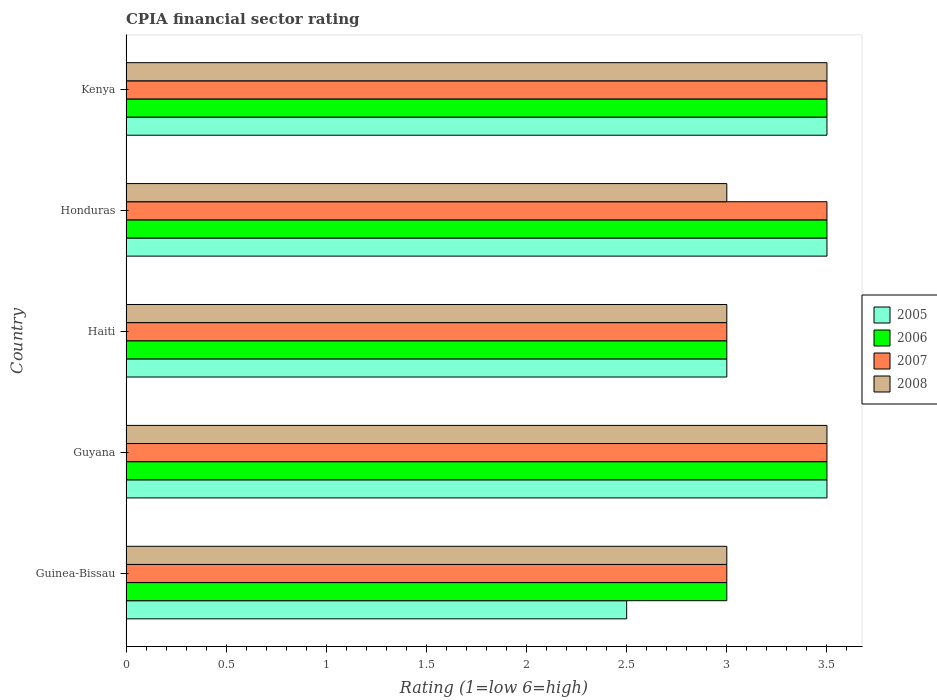How many different coloured bars are there?
Provide a short and direct response. 4. Are the number of bars per tick equal to the number of legend labels?
Provide a succinct answer. Yes. How many bars are there on the 4th tick from the bottom?
Your response must be concise. 4. What is the label of the 2nd group of bars from the top?
Offer a terse response. Honduras. Across all countries, what is the maximum CPIA rating in 2008?
Your answer should be very brief. 3.5. Across all countries, what is the minimum CPIA rating in 2007?
Offer a terse response. 3. In which country was the CPIA rating in 2006 maximum?
Make the answer very short. Guyana. In which country was the CPIA rating in 2007 minimum?
Your answer should be compact. Guinea-Bissau. What is the difference between the CPIA rating in 2007 in Kenya and the CPIA rating in 2008 in Honduras?
Give a very brief answer. 0.5. In how many countries, is the CPIA rating in 2007 greater than 1.6 ?
Provide a succinct answer. 5. What is the ratio of the CPIA rating in 2006 in Guinea-Bissau to that in Honduras?
Make the answer very short. 0.86. Is the CPIA rating in 2005 in Guyana less than that in Honduras?
Give a very brief answer. No. What is the difference between the highest and the lowest CPIA rating in 2006?
Your answer should be very brief. 0.5. In how many countries, is the CPIA rating in 2006 greater than the average CPIA rating in 2006 taken over all countries?
Provide a succinct answer. 3. Is it the case that in every country, the sum of the CPIA rating in 2007 and CPIA rating in 2006 is greater than the sum of CPIA rating in 2005 and CPIA rating in 2008?
Make the answer very short. No. What does the 3rd bar from the bottom in Guinea-Bissau represents?
Your answer should be very brief. 2007. How many bars are there?
Your answer should be very brief. 20. Are all the bars in the graph horizontal?
Keep it short and to the point. Yes. How many countries are there in the graph?
Your response must be concise. 5. What is the difference between two consecutive major ticks on the X-axis?
Keep it short and to the point. 0.5. Where does the legend appear in the graph?
Ensure brevity in your answer.  Center right. How many legend labels are there?
Make the answer very short. 4. How are the legend labels stacked?
Provide a short and direct response. Vertical. What is the title of the graph?
Your answer should be compact. CPIA financial sector rating. Does "2011" appear as one of the legend labels in the graph?
Ensure brevity in your answer.  No. What is the label or title of the Y-axis?
Make the answer very short. Country. What is the Rating (1=low 6=high) of 2005 in Guinea-Bissau?
Provide a short and direct response. 2.5. What is the Rating (1=low 6=high) of 2007 in Guinea-Bissau?
Make the answer very short. 3. What is the Rating (1=low 6=high) in 2006 in Guyana?
Ensure brevity in your answer.  3.5. What is the Rating (1=low 6=high) in 2008 in Guyana?
Offer a terse response. 3.5. What is the Rating (1=low 6=high) of 2008 in Haiti?
Make the answer very short. 3. What is the Rating (1=low 6=high) in 2006 in Honduras?
Make the answer very short. 3.5. What is the Rating (1=low 6=high) of 2008 in Honduras?
Your answer should be compact. 3. What is the Rating (1=low 6=high) of 2006 in Kenya?
Offer a very short reply. 3.5. What is the Rating (1=low 6=high) of 2008 in Kenya?
Offer a very short reply. 3.5. Across all countries, what is the maximum Rating (1=low 6=high) of 2005?
Make the answer very short. 3.5. Across all countries, what is the minimum Rating (1=low 6=high) of 2005?
Your answer should be compact. 2.5. Across all countries, what is the minimum Rating (1=low 6=high) in 2006?
Offer a very short reply. 3. Across all countries, what is the minimum Rating (1=low 6=high) in 2007?
Give a very brief answer. 3. What is the difference between the Rating (1=low 6=high) of 2007 in Guinea-Bissau and that in Guyana?
Make the answer very short. -0.5. What is the difference between the Rating (1=low 6=high) of 2008 in Guinea-Bissau and that in Guyana?
Your response must be concise. -0.5. What is the difference between the Rating (1=low 6=high) in 2006 in Guinea-Bissau and that in Haiti?
Offer a terse response. 0. What is the difference between the Rating (1=low 6=high) of 2005 in Guinea-Bissau and that in Kenya?
Ensure brevity in your answer.  -1. What is the difference between the Rating (1=low 6=high) of 2007 in Guinea-Bissau and that in Kenya?
Keep it short and to the point. -0.5. What is the difference between the Rating (1=low 6=high) of 2008 in Guinea-Bissau and that in Kenya?
Provide a short and direct response. -0.5. What is the difference between the Rating (1=low 6=high) of 2005 in Guyana and that in Haiti?
Your answer should be very brief. 0.5. What is the difference between the Rating (1=low 6=high) of 2007 in Guyana and that in Haiti?
Your answer should be compact. 0.5. What is the difference between the Rating (1=low 6=high) in 2008 in Guyana and that in Haiti?
Keep it short and to the point. 0.5. What is the difference between the Rating (1=low 6=high) in 2007 in Guyana and that in Honduras?
Your response must be concise. 0. What is the difference between the Rating (1=low 6=high) in 2005 in Guyana and that in Kenya?
Provide a succinct answer. 0. What is the difference between the Rating (1=low 6=high) in 2006 in Guyana and that in Kenya?
Give a very brief answer. 0. What is the difference between the Rating (1=low 6=high) of 2007 in Guyana and that in Kenya?
Offer a very short reply. 0. What is the difference between the Rating (1=low 6=high) in 2008 in Guyana and that in Kenya?
Ensure brevity in your answer.  0. What is the difference between the Rating (1=low 6=high) in 2005 in Haiti and that in Honduras?
Your answer should be very brief. -0.5. What is the difference between the Rating (1=low 6=high) of 2007 in Haiti and that in Honduras?
Your answer should be compact. -0.5. What is the difference between the Rating (1=low 6=high) in 2006 in Honduras and that in Kenya?
Your response must be concise. 0. What is the difference between the Rating (1=low 6=high) in 2005 in Guinea-Bissau and the Rating (1=low 6=high) in 2006 in Guyana?
Make the answer very short. -1. What is the difference between the Rating (1=low 6=high) in 2006 in Guinea-Bissau and the Rating (1=low 6=high) in 2008 in Guyana?
Your answer should be compact. -0.5. What is the difference between the Rating (1=low 6=high) in 2007 in Guinea-Bissau and the Rating (1=low 6=high) in 2008 in Guyana?
Ensure brevity in your answer.  -0.5. What is the difference between the Rating (1=low 6=high) of 2006 in Guinea-Bissau and the Rating (1=low 6=high) of 2008 in Haiti?
Provide a succinct answer. 0. What is the difference between the Rating (1=low 6=high) of 2007 in Guinea-Bissau and the Rating (1=low 6=high) of 2008 in Haiti?
Your response must be concise. 0. What is the difference between the Rating (1=low 6=high) in 2006 in Guinea-Bissau and the Rating (1=low 6=high) in 2008 in Honduras?
Your answer should be very brief. 0. What is the difference between the Rating (1=low 6=high) in 2007 in Guinea-Bissau and the Rating (1=low 6=high) in 2008 in Honduras?
Make the answer very short. 0. What is the difference between the Rating (1=low 6=high) of 2005 in Guinea-Bissau and the Rating (1=low 6=high) of 2007 in Kenya?
Ensure brevity in your answer.  -1. What is the difference between the Rating (1=low 6=high) of 2006 in Guinea-Bissau and the Rating (1=low 6=high) of 2008 in Kenya?
Your answer should be very brief. -0.5. What is the difference between the Rating (1=low 6=high) in 2007 in Guinea-Bissau and the Rating (1=low 6=high) in 2008 in Kenya?
Give a very brief answer. -0.5. What is the difference between the Rating (1=low 6=high) of 2005 in Guyana and the Rating (1=low 6=high) of 2007 in Haiti?
Offer a very short reply. 0.5. What is the difference between the Rating (1=low 6=high) in 2006 in Guyana and the Rating (1=low 6=high) in 2007 in Haiti?
Your answer should be very brief. 0.5. What is the difference between the Rating (1=low 6=high) of 2005 in Guyana and the Rating (1=low 6=high) of 2008 in Honduras?
Offer a very short reply. 0.5. What is the difference between the Rating (1=low 6=high) in 2006 in Guyana and the Rating (1=low 6=high) in 2007 in Honduras?
Your answer should be compact. 0. What is the difference between the Rating (1=low 6=high) in 2006 in Guyana and the Rating (1=low 6=high) in 2008 in Honduras?
Your answer should be very brief. 0.5. What is the difference between the Rating (1=low 6=high) in 2005 in Guyana and the Rating (1=low 6=high) in 2006 in Kenya?
Keep it short and to the point. 0. What is the difference between the Rating (1=low 6=high) in 2005 in Guyana and the Rating (1=low 6=high) in 2007 in Kenya?
Offer a terse response. 0. What is the difference between the Rating (1=low 6=high) in 2006 in Guyana and the Rating (1=low 6=high) in 2008 in Kenya?
Your answer should be compact. 0. What is the difference between the Rating (1=low 6=high) of 2007 in Guyana and the Rating (1=low 6=high) of 2008 in Kenya?
Keep it short and to the point. 0. What is the difference between the Rating (1=low 6=high) in 2005 in Haiti and the Rating (1=low 6=high) in 2007 in Honduras?
Your answer should be compact. -0.5. What is the difference between the Rating (1=low 6=high) in 2006 in Haiti and the Rating (1=low 6=high) in 2007 in Honduras?
Your answer should be compact. -0.5. What is the difference between the Rating (1=low 6=high) of 2005 in Haiti and the Rating (1=low 6=high) of 2006 in Kenya?
Offer a terse response. -0.5. What is the difference between the Rating (1=low 6=high) in 2005 in Haiti and the Rating (1=low 6=high) in 2007 in Kenya?
Provide a short and direct response. -0.5. What is the difference between the Rating (1=low 6=high) of 2005 in Haiti and the Rating (1=low 6=high) of 2008 in Kenya?
Make the answer very short. -0.5. What is the difference between the Rating (1=low 6=high) in 2006 in Haiti and the Rating (1=low 6=high) in 2007 in Kenya?
Ensure brevity in your answer.  -0.5. What is the difference between the Rating (1=low 6=high) of 2006 in Haiti and the Rating (1=low 6=high) of 2008 in Kenya?
Offer a terse response. -0.5. What is the difference between the Rating (1=low 6=high) in 2007 in Haiti and the Rating (1=low 6=high) in 2008 in Kenya?
Offer a terse response. -0.5. What is the difference between the Rating (1=low 6=high) in 2005 in Honduras and the Rating (1=low 6=high) in 2006 in Kenya?
Provide a short and direct response. 0. What is the difference between the Rating (1=low 6=high) in 2005 in Honduras and the Rating (1=low 6=high) in 2007 in Kenya?
Offer a very short reply. 0. What is the difference between the Rating (1=low 6=high) of 2006 in Honduras and the Rating (1=low 6=high) of 2007 in Kenya?
Provide a succinct answer. 0. What is the difference between the Rating (1=low 6=high) of 2006 in Honduras and the Rating (1=low 6=high) of 2008 in Kenya?
Offer a terse response. 0. What is the difference between the Rating (1=low 6=high) in 2007 in Honduras and the Rating (1=low 6=high) in 2008 in Kenya?
Your answer should be very brief. 0. What is the average Rating (1=low 6=high) in 2005 per country?
Give a very brief answer. 3.2. What is the average Rating (1=low 6=high) in 2008 per country?
Give a very brief answer. 3.2. What is the difference between the Rating (1=low 6=high) of 2006 and Rating (1=low 6=high) of 2007 in Guinea-Bissau?
Offer a very short reply. 0. What is the difference between the Rating (1=low 6=high) of 2006 and Rating (1=low 6=high) of 2008 in Guinea-Bissau?
Provide a succinct answer. 0. What is the difference between the Rating (1=low 6=high) in 2007 and Rating (1=low 6=high) in 2008 in Guinea-Bissau?
Offer a very short reply. 0. What is the difference between the Rating (1=low 6=high) in 2005 and Rating (1=low 6=high) in 2006 in Guyana?
Give a very brief answer. 0. What is the difference between the Rating (1=low 6=high) in 2007 and Rating (1=low 6=high) in 2008 in Guyana?
Your answer should be compact. 0. What is the difference between the Rating (1=low 6=high) in 2005 and Rating (1=low 6=high) in 2007 in Haiti?
Keep it short and to the point. 0. What is the difference between the Rating (1=low 6=high) of 2007 and Rating (1=low 6=high) of 2008 in Haiti?
Give a very brief answer. 0. What is the difference between the Rating (1=low 6=high) of 2005 and Rating (1=low 6=high) of 2006 in Honduras?
Offer a very short reply. 0. What is the difference between the Rating (1=low 6=high) of 2005 and Rating (1=low 6=high) of 2008 in Honduras?
Make the answer very short. 0.5. What is the difference between the Rating (1=low 6=high) of 2006 and Rating (1=low 6=high) of 2007 in Honduras?
Ensure brevity in your answer.  0. What is the difference between the Rating (1=low 6=high) in 2006 and Rating (1=low 6=high) in 2008 in Honduras?
Offer a terse response. 0.5. What is the difference between the Rating (1=low 6=high) in 2007 and Rating (1=low 6=high) in 2008 in Honduras?
Your answer should be very brief. 0.5. What is the difference between the Rating (1=low 6=high) of 2005 and Rating (1=low 6=high) of 2007 in Kenya?
Give a very brief answer. 0. What is the difference between the Rating (1=low 6=high) in 2005 and Rating (1=low 6=high) in 2008 in Kenya?
Provide a succinct answer. 0. What is the difference between the Rating (1=low 6=high) of 2006 and Rating (1=low 6=high) of 2008 in Kenya?
Provide a succinct answer. 0. What is the ratio of the Rating (1=low 6=high) in 2005 in Guinea-Bissau to that in Haiti?
Your answer should be very brief. 0.83. What is the ratio of the Rating (1=low 6=high) in 2006 in Guinea-Bissau to that in Haiti?
Offer a very short reply. 1. What is the ratio of the Rating (1=low 6=high) in 2005 in Guinea-Bissau to that in Honduras?
Ensure brevity in your answer.  0.71. What is the ratio of the Rating (1=low 6=high) in 2008 in Guinea-Bissau to that in Honduras?
Give a very brief answer. 1. What is the ratio of the Rating (1=low 6=high) in 2006 in Guinea-Bissau to that in Kenya?
Make the answer very short. 0.86. What is the ratio of the Rating (1=low 6=high) of 2005 in Guyana to that in Haiti?
Ensure brevity in your answer.  1.17. What is the ratio of the Rating (1=low 6=high) in 2008 in Guyana to that in Haiti?
Your answer should be compact. 1.17. What is the ratio of the Rating (1=low 6=high) of 2008 in Guyana to that in Honduras?
Keep it short and to the point. 1.17. What is the ratio of the Rating (1=low 6=high) in 2006 in Guyana to that in Kenya?
Keep it short and to the point. 1. What is the ratio of the Rating (1=low 6=high) of 2007 in Guyana to that in Kenya?
Ensure brevity in your answer.  1. What is the ratio of the Rating (1=low 6=high) in 2008 in Guyana to that in Kenya?
Give a very brief answer. 1. What is the ratio of the Rating (1=low 6=high) of 2006 in Haiti to that in Kenya?
Your answer should be compact. 0.86. What is the ratio of the Rating (1=low 6=high) of 2007 in Haiti to that in Kenya?
Make the answer very short. 0.86. What is the ratio of the Rating (1=low 6=high) of 2006 in Honduras to that in Kenya?
Provide a succinct answer. 1. What is the ratio of the Rating (1=low 6=high) in 2008 in Honduras to that in Kenya?
Your response must be concise. 0.86. What is the difference between the highest and the second highest Rating (1=low 6=high) in 2005?
Your answer should be compact. 0. What is the difference between the highest and the second highest Rating (1=low 6=high) of 2007?
Keep it short and to the point. 0. What is the difference between the highest and the second highest Rating (1=low 6=high) in 2008?
Ensure brevity in your answer.  0. What is the difference between the highest and the lowest Rating (1=low 6=high) in 2005?
Your answer should be compact. 1. What is the difference between the highest and the lowest Rating (1=low 6=high) in 2007?
Your answer should be very brief. 0.5. 